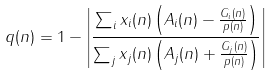<formula> <loc_0><loc_0><loc_500><loc_500>q ( n ) = 1 - \left | \frac { \sum _ { i } x _ { i } ( n ) \left ( A _ { i } ( n ) - \frac { G _ { i } ( n ) } { p ( n ) } \right ) } { \sum _ { j } x _ { j } ( n ) \left ( A _ { j } ( n ) + \frac { G _ { j } ( n ) } { p ( n ) } \right ) } \right |</formula> 